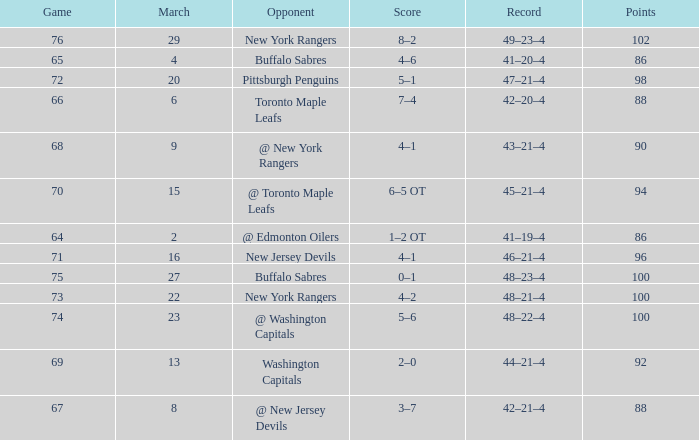Which March is the lowest one that has a Score of 5–6, and Points smaller than 100? None. 